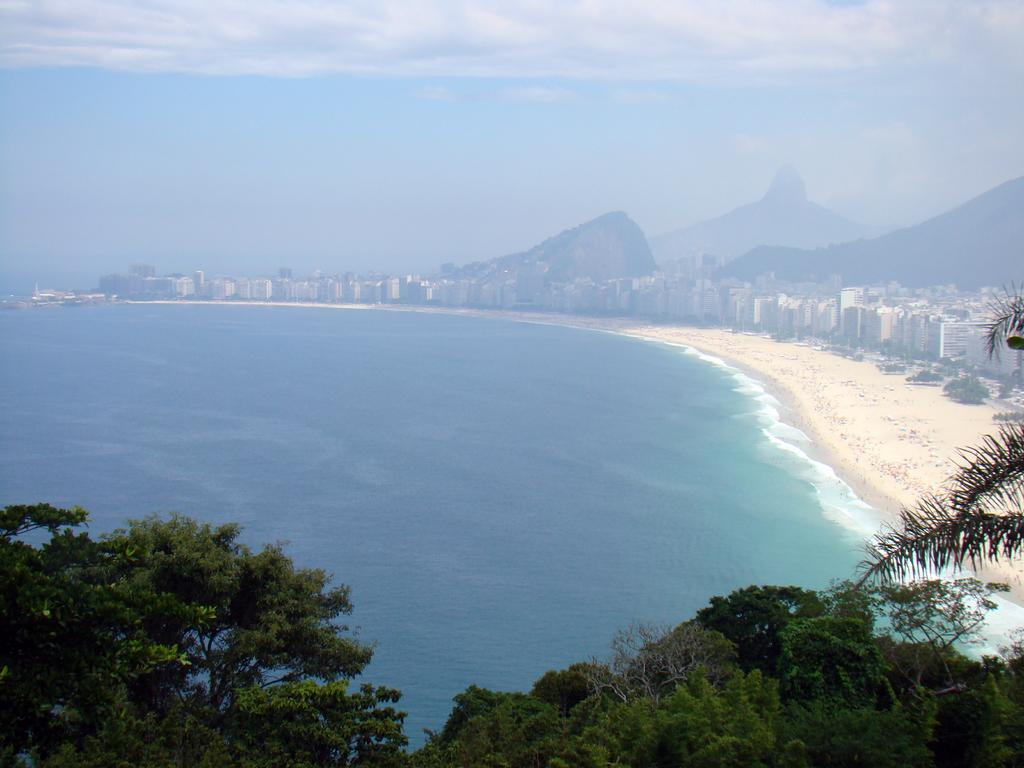What type of natural elements can be seen in the image? There are trees and plants visible in the image. What type of man-made structures can be seen in the image? There are buildings visible in the image. What type of terrain is visible in the image? There is water and mountains visible in the image. What is visible in the background of the image? The sky is visible in the background of the image. What is the condition of the sky in the image? The sky has clouds visible in it. What type of silver thing can be seen in the image? There is no silver object present in the image. How many houses are visible in the image? The image does not show any houses; it features buildings, but the specific type of structure is not specified. 